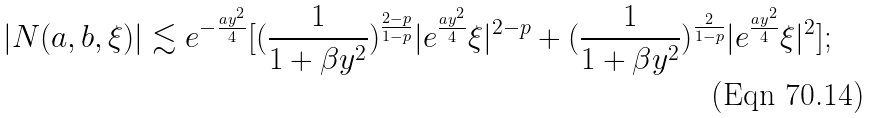<formula> <loc_0><loc_0><loc_500><loc_500>| N ( a , b , \xi ) | \lesssim e ^ { - \frac { a y ^ { 2 } } { 4 } } [ ( \frac { 1 } { 1 + \beta y ^ { 2 } } ) ^ { \frac { 2 - p } { 1 - p } } | e ^ { \frac { a y ^ { 2 } } { 4 } } \xi | ^ { 2 - p } + ( \frac { 1 } { 1 + \beta y ^ { 2 } } ) ^ { \frac { 2 } { 1 - p } } | e ^ { \frac { a y ^ { 2 } } { 4 } } \xi | ^ { 2 } ] ;</formula> 